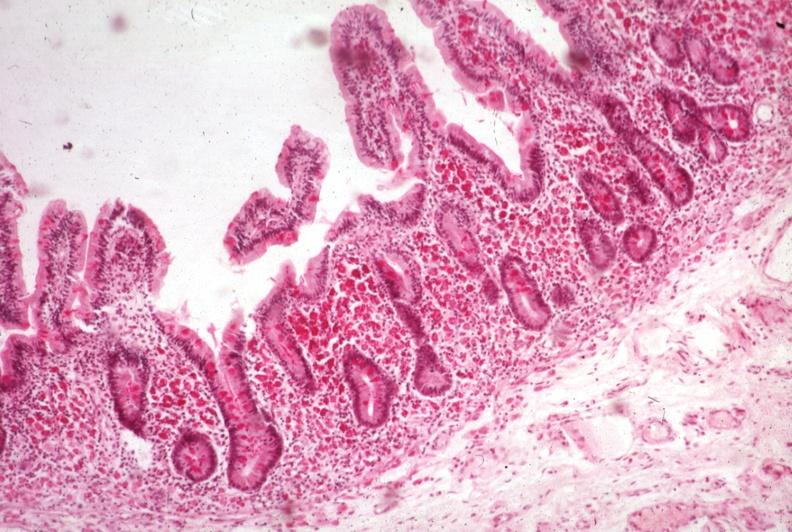what does this image show?
Answer the question using a single word or phrase. Pas hematoxylin 